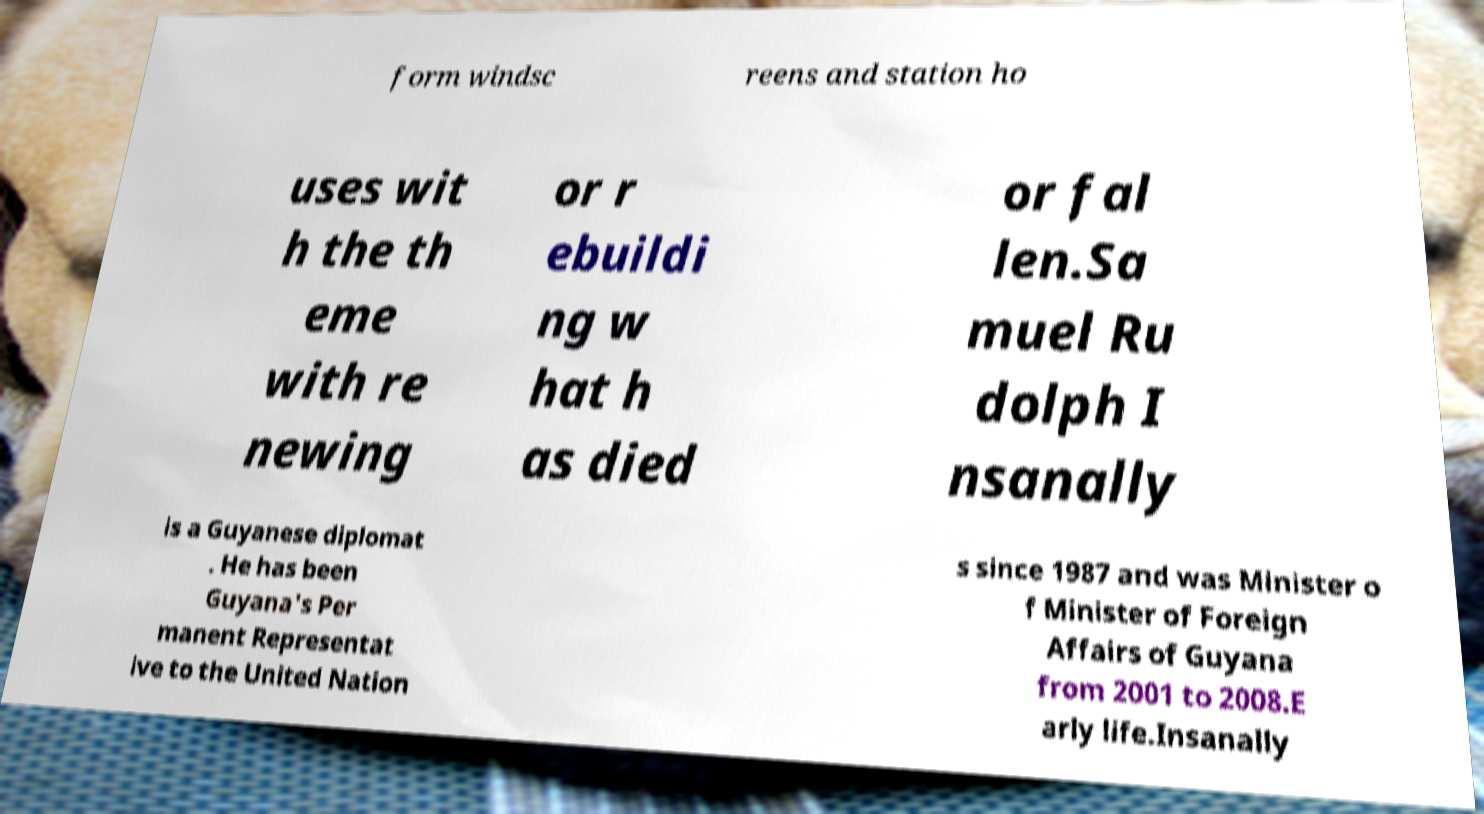There's text embedded in this image that I need extracted. Can you transcribe it verbatim? form windsc reens and station ho uses wit h the th eme with re newing or r ebuildi ng w hat h as died or fal len.Sa muel Ru dolph I nsanally is a Guyanese diplomat . He has been Guyana's Per manent Representat ive to the United Nation s since 1987 and was Minister o f Minister of Foreign Affairs of Guyana from 2001 to 2008.E arly life.Insanally 